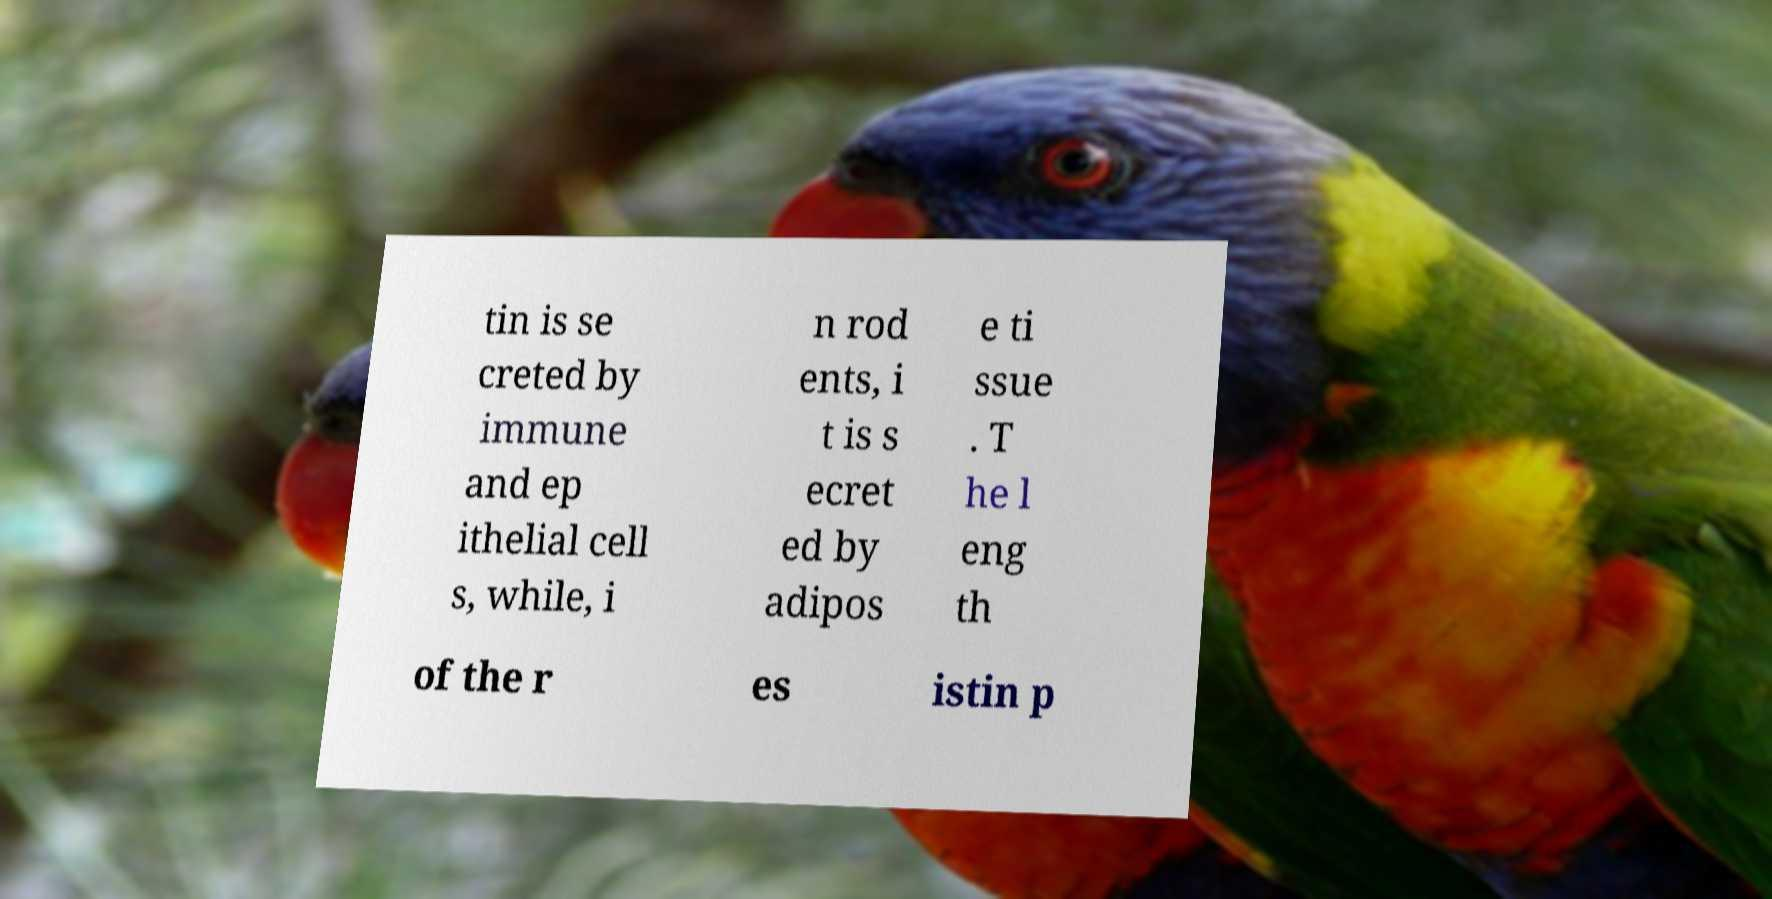For documentation purposes, I need the text within this image transcribed. Could you provide that? tin is se creted by immune and ep ithelial cell s, while, i n rod ents, i t is s ecret ed by adipos e ti ssue . T he l eng th of the r es istin p 